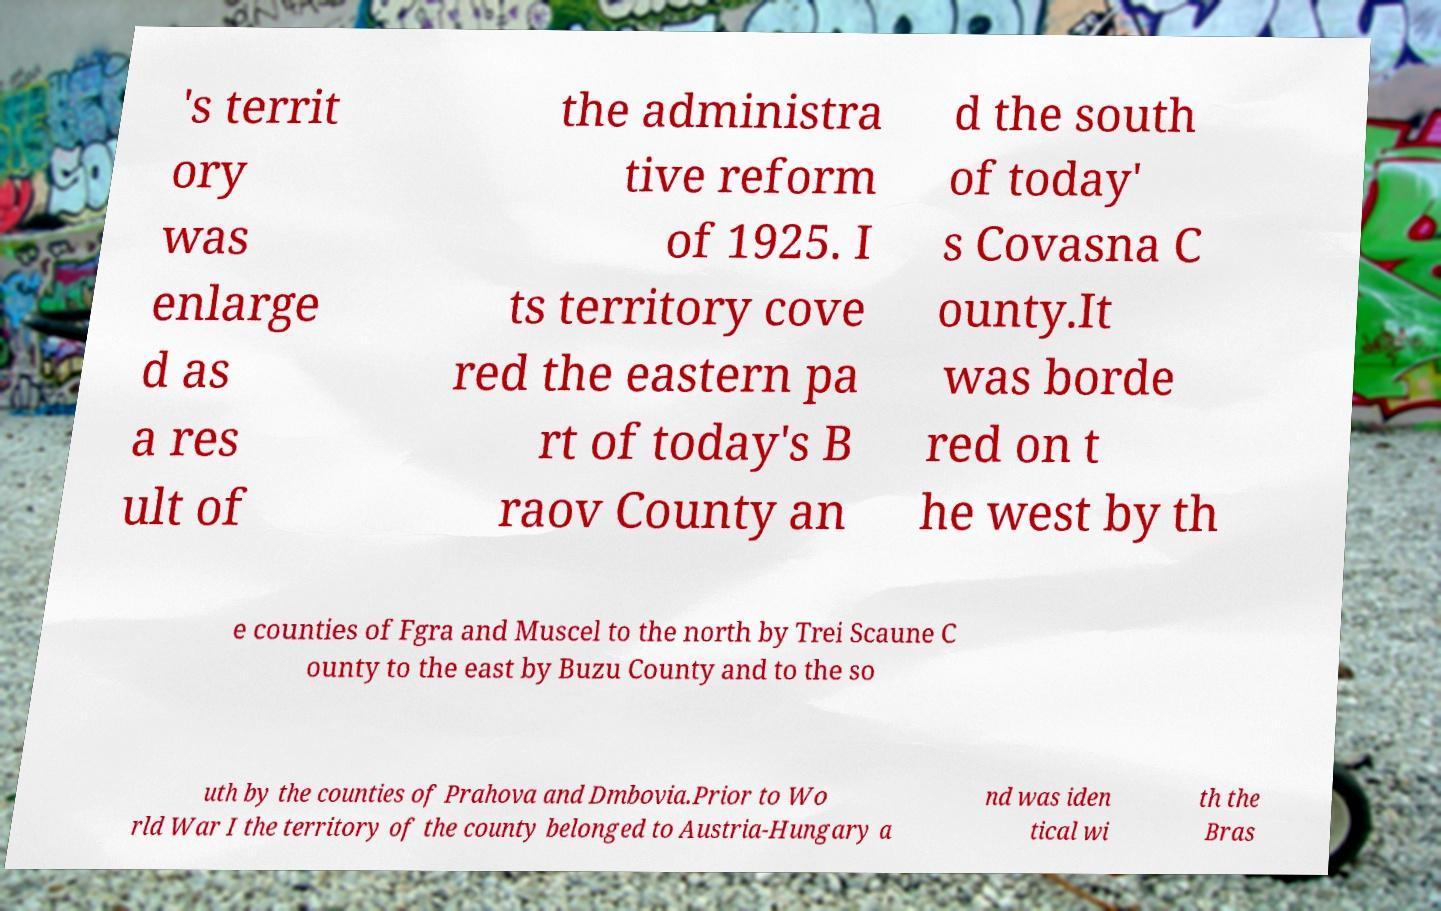I need the written content from this picture converted into text. Can you do that? 's territ ory was enlarge d as a res ult of the administra tive reform of 1925. I ts territory cove red the eastern pa rt of today's B raov County an d the south of today' s Covasna C ounty.It was borde red on t he west by th e counties of Fgra and Muscel to the north by Trei Scaune C ounty to the east by Buzu County and to the so uth by the counties of Prahova and Dmbovia.Prior to Wo rld War I the territory of the county belonged to Austria-Hungary a nd was iden tical wi th the Bras 